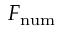<formula> <loc_0><loc_0><loc_500><loc_500>F _ { n u m }</formula> 